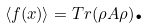Convert formula to latex. <formula><loc_0><loc_0><loc_500><loc_500>\left \langle f ( x ) \right \rangle = T r ( \rho A \rho ) \text {.}</formula> 